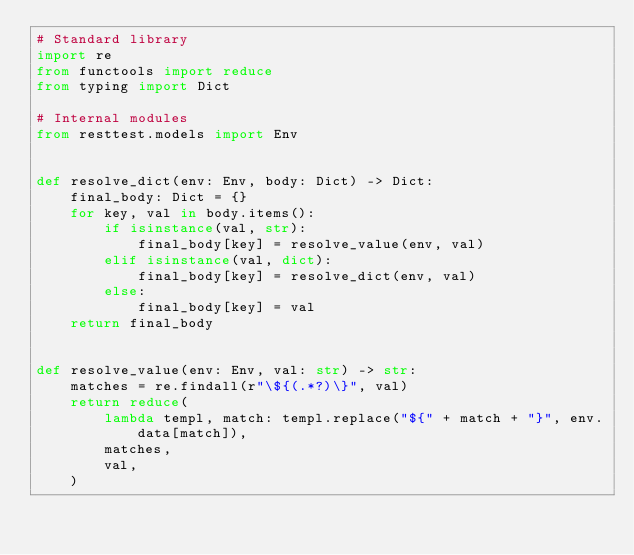Convert code to text. <code><loc_0><loc_0><loc_500><loc_500><_Python_># Standard library
import re
from functools import reduce
from typing import Dict

# Internal modules
from resttest.models import Env


def resolve_dict(env: Env, body: Dict) -> Dict:
    final_body: Dict = {}
    for key, val in body.items():
        if isinstance(val, str):
            final_body[key] = resolve_value(env, val)
        elif isinstance(val, dict):
            final_body[key] = resolve_dict(env, val)
        else:
            final_body[key] = val
    return final_body


def resolve_value(env: Env, val: str) -> str:
    matches = re.findall(r"\${(.*?)\}", val)
    return reduce(
        lambda templ, match: templ.replace("${" + match + "}", env.data[match]),
        matches,
        val,
    )

</code> 